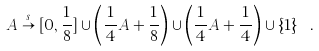<formula> <loc_0><loc_0><loc_500><loc_500>A \stackrel { s } { \to } [ 0 , \frac { 1 } { 8 } ] \cup \left ( \frac { 1 } { 4 } A + \frac { 1 } { 8 } \right ) \cup \left ( \frac { 1 } { 4 } A + \frac { 1 } { 4 } \right ) \cup \{ 1 \} \ .</formula> 